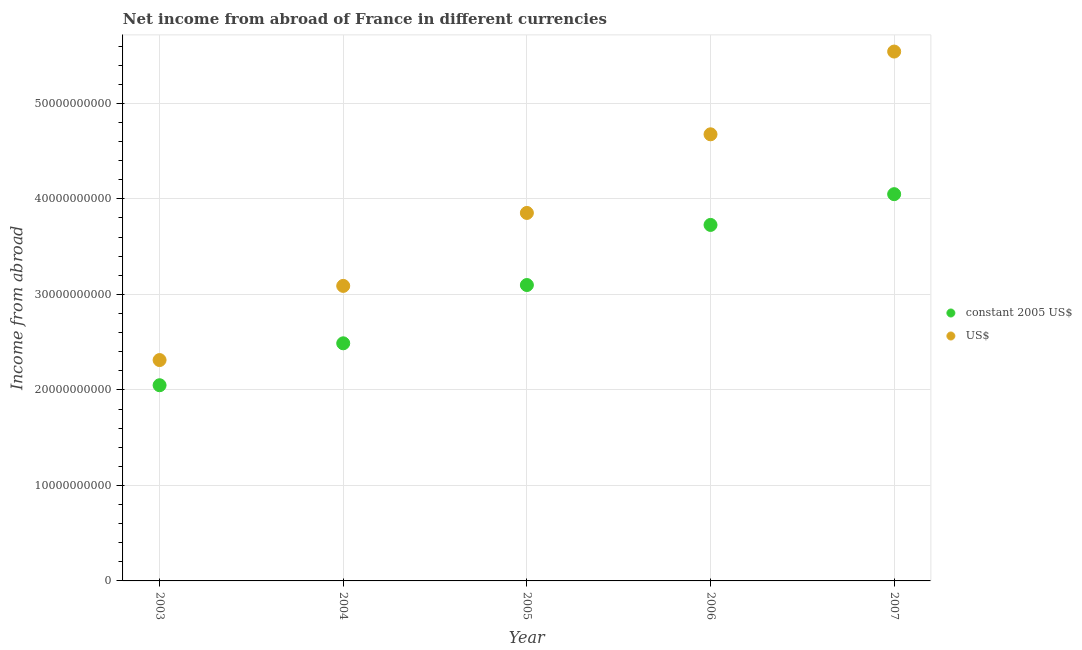Is the number of dotlines equal to the number of legend labels?
Provide a succinct answer. Yes. What is the income from abroad in us$ in 2007?
Provide a short and direct response. 5.54e+1. Across all years, what is the maximum income from abroad in us$?
Provide a succinct answer. 5.54e+1. Across all years, what is the minimum income from abroad in constant 2005 us$?
Make the answer very short. 2.05e+1. In which year was the income from abroad in us$ minimum?
Offer a terse response. 2003. What is the total income from abroad in us$ in the graph?
Your answer should be compact. 1.95e+11. What is the difference between the income from abroad in us$ in 2005 and that in 2006?
Your answer should be compact. -8.23e+09. What is the difference between the income from abroad in constant 2005 us$ in 2006 and the income from abroad in us$ in 2005?
Keep it short and to the point. -1.25e+09. What is the average income from abroad in constant 2005 us$ per year?
Offer a terse response. 3.08e+1. In the year 2006, what is the difference between the income from abroad in us$ and income from abroad in constant 2005 us$?
Your answer should be compact. 9.49e+09. What is the ratio of the income from abroad in constant 2005 us$ in 2003 to that in 2005?
Keep it short and to the point. 0.66. Is the income from abroad in constant 2005 us$ in 2003 less than that in 2007?
Your response must be concise. Yes. Is the difference between the income from abroad in us$ in 2004 and 2006 greater than the difference between the income from abroad in constant 2005 us$ in 2004 and 2006?
Your answer should be compact. No. What is the difference between the highest and the second highest income from abroad in constant 2005 us$?
Ensure brevity in your answer.  3.22e+09. What is the difference between the highest and the lowest income from abroad in constant 2005 us$?
Give a very brief answer. 2.00e+1. Does the income from abroad in us$ monotonically increase over the years?
Offer a very short reply. Yes. How many years are there in the graph?
Offer a terse response. 5. What is the difference between two consecutive major ticks on the Y-axis?
Give a very brief answer. 1.00e+1. Are the values on the major ticks of Y-axis written in scientific E-notation?
Provide a succinct answer. No. Does the graph contain any zero values?
Your response must be concise. No. How many legend labels are there?
Your answer should be compact. 2. How are the legend labels stacked?
Make the answer very short. Vertical. What is the title of the graph?
Make the answer very short. Net income from abroad of France in different currencies. Does "Young" appear as one of the legend labels in the graph?
Make the answer very short. No. What is the label or title of the Y-axis?
Your answer should be compact. Income from abroad. What is the Income from abroad of constant 2005 US$ in 2003?
Your response must be concise. 2.05e+1. What is the Income from abroad in US$ in 2003?
Give a very brief answer. 2.31e+1. What is the Income from abroad in constant 2005 US$ in 2004?
Your response must be concise. 2.49e+1. What is the Income from abroad of US$ in 2004?
Your answer should be compact. 3.09e+1. What is the Income from abroad of constant 2005 US$ in 2005?
Your answer should be very brief. 3.10e+1. What is the Income from abroad of US$ in 2005?
Ensure brevity in your answer.  3.85e+1. What is the Income from abroad in constant 2005 US$ in 2006?
Make the answer very short. 3.73e+1. What is the Income from abroad of US$ in 2006?
Make the answer very short. 4.68e+1. What is the Income from abroad of constant 2005 US$ in 2007?
Your answer should be compact. 4.05e+1. What is the Income from abroad of US$ in 2007?
Your answer should be compact. 5.54e+1. Across all years, what is the maximum Income from abroad of constant 2005 US$?
Provide a short and direct response. 4.05e+1. Across all years, what is the maximum Income from abroad in US$?
Your response must be concise. 5.54e+1. Across all years, what is the minimum Income from abroad of constant 2005 US$?
Offer a terse response. 2.05e+1. Across all years, what is the minimum Income from abroad of US$?
Your answer should be very brief. 2.31e+1. What is the total Income from abroad in constant 2005 US$ in the graph?
Offer a very short reply. 1.54e+11. What is the total Income from abroad in US$ in the graph?
Give a very brief answer. 1.95e+11. What is the difference between the Income from abroad of constant 2005 US$ in 2003 and that in 2004?
Offer a very short reply. -4.39e+09. What is the difference between the Income from abroad in US$ in 2003 and that in 2004?
Give a very brief answer. -7.76e+09. What is the difference between the Income from abroad in constant 2005 US$ in 2003 and that in 2005?
Make the answer very short. -1.05e+1. What is the difference between the Income from abroad in US$ in 2003 and that in 2005?
Your response must be concise. -1.54e+1. What is the difference between the Income from abroad in constant 2005 US$ in 2003 and that in 2006?
Provide a short and direct response. -1.68e+1. What is the difference between the Income from abroad in US$ in 2003 and that in 2006?
Ensure brevity in your answer.  -2.36e+1. What is the difference between the Income from abroad of constant 2005 US$ in 2003 and that in 2007?
Offer a very short reply. -2.00e+1. What is the difference between the Income from abroad of US$ in 2003 and that in 2007?
Offer a terse response. -3.23e+1. What is the difference between the Income from abroad of constant 2005 US$ in 2004 and that in 2005?
Make the answer very short. -6.10e+09. What is the difference between the Income from abroad of US$ in 2004 and that in 2005?
Your response must be concise. -7.64e+09. What is the difference between the Income from abroad in constant 2005 US$ in 2004 and that in 2006?
Offer a very short reply. -1.24e+1. What is the difference between the Income from abroad of US$ in 2004 and that in 2006?
Make the answer very short. -1.59e+1. What is the difference between the Income from abroad of constant 2005 US$ in 2004 and that in 2007?
Make the answer very short. -1.56e+1. What is the difference between the Income from abroad of US$ in 2004 and that in 2007?
Your response must be concise. -2.45e+1. What is the difference between the Income from abroad in constant 2005 US$ in 2005 and that in 2006?
Offer a very short reply. -6.29e+09. What is the difference between the Income from abroad of US$ in 2005 and that in 2006?
Give a very brief answer. -8.23e+09. What is the difference between the Income from abroad in constant 2005 US$ in 2005 and that in 2007?
Your answer should be compact. -9.51e+09. What is the difference between the Income from abroad of US$ in 2005 and that in 2007?
Offer a very short reply. -1.69e+1. What is the difference between the Income from abroad of constant 2005 US$ in 2006 and that in 2007?
Offer a very short reply. -3.22e+09. What is the difference between the Income from abroad in US$ in 2006 and that in 2007?
Provide a short and direct response. -8.66e+09. What is the difference between the Income from abroad of constant 2005 US$ in 2003 and the Income from abroad of US$ in 2004?
Make the answer very short. -1.04e+1. What is the difference between the Income from abroad of constant 2005 US$ in 2003 and the Income from abroad of US$ in 2005?
Provide a succinct answer. -1.80e+1. What is the difference between the Income from abroad in constant 2005 US$ in 2003 and the Income from abroad in US$ in 2006?
Give a very brief answer. -2.63e+1. What is the difference between the Income from abroad in constant 2005 US$ in 2003 and the Income from abroad in US$ in 2007?
Ensure brevity in your answer.  -3.49e+1. What is the difference between the Income from abroad in constant 2005 US$ in 2004 and the Income from abroad in US$ in 2005?
Provide a succinct answer. -1.36e+1. What is the difference between the Income from abroad of constant 2005 US$ in 2004 and the Income from abroad of US$ in 2006?
Your response must be concise. -2.19e+1. What is the difference between the Income from abroad of constant 2005 US$ in 2004 and the Income from abroad of US$ in 2007?
Your response must be concise. -3.05e+1. What is the difference between the Income from abroad in constant 2005 US$ in 2005 and the Income from abroad in US$ in 2006?
Your response must be concise. -1.58e+1. What is the difference between the Income from abroad of constant 2005 US$ in 2005 and the Income from abroad of US$ in 2007?
Give a very brief answer. -2.44e+1. What is the difference between the Income from abroad in constant 2005 US$ in 2006 and the Income from abroad in US$ in 2007?
Make the answer very short. -1.82e+1. What is the average Income from abroad of constant 2005 US$ per year?
Offer a very short reply. 3.08e+1. What is the average Income from abroad in US$ per year?
Give a very brief answer. 3.89e+1. In the year 2003, what is the difference between the Income from abroad of constant 2005 US$ and Income from abroad of US$?
Your answer should be compact. -2.64e+09. In the year 2004, what is the difference between the Income from abroad of constant 2005 US$ and Income from abroad of US$?
Provide a short and direct response. -6.01e+09. In the year 2005, what is the difference between the Income from abroad in constant 2005 US$ and Income from abroad in US$?
Give a very brief answer. -7.55e+09. In the year 2006, what is the difference between the Income from abroad in constant 2005 US$ and Income from abroad in US$?
Your answer should be compact. -9.49e+09. In the year 2007, what is the difference between the Income from abroad of constant 2005 US$ and Income from abroad of US$?
Give a very brief answer. -1.49e+1. What is the ratio of the Income from abroad of constant 2005 US$ in 2003 to that in 2004?
Ensure brevity in your answer.  0.82. What is the ratio of the Income from abroad of US$ in 2003 to that in 2004?
Provide a short and direct response. 0.75. What is the ratio of the Income from abroad of constant 2005 US$ in 2003 to that in 2005?
Give a very brief answer. 0.66. What is the ratio of the Income from abroad in US$ in 2003 to that in 2005?
Keep it short and to the point. 0.6. What is the ratio of the Income from abroad of constant 2005 US$ in 2003 to that in 2006?
Your response must be concise. 0.55. What is the ratio of the Income from abroad in US$ in 2003 to that in 2006?
Your answer should be compact. 0.49. What is the ratio of the Income from abroad of constant 2005 US$ in 2003 to that in 2007?
Give a very brief answer. 0.51. What is the ratio of the Income from abroad of US$ in 2003 to that in 2007?
Make the answer very short. 0.42. What is the ratio of the Income from abroad in constant 2005 US$ in 2004 to that in 2005?
Your answer should be very brief. 0.8. What is the ratio of the Income from abroad of US$ in 2004 to that in 2005?
Provide a succinct answer. 0.8. What is the ratio of the Income from abroad in constant 2005 US$ in 2004 to that in 2006?
Ensure brevity in your answer.  0.67. What is the ratio of the Income from abroad in US$ in 2004 to that in 2006?
Offer a very short reply. 0.66. What is the ratio of the Income from abroad in constant 2005 US$ in 2004 to that in 2007?
Provide a short and direct response. 0.61. What is the ratio of the Income from abroad of US$ in 2004 to that in 2007?
Offer a terse response. 0.56. What is the ratio of the Income from abroad of constant 2005 US$ in 2005 to that in 2006?
Your answer should be compact. 0.83. What is the ratio of the Income from abroad of US$ in 2005 to that in 2006?
Ensure brevity in your answer.  0.82. What is the ratio of the Income from abroad in constant 2005 US$ in 2005 to that in 2007?
Your answer should be compact. 0.77. What is the ratio of the Income from abroad of US$ in 2005 to that in 2007?
Offer a terse response. 0.7. What is the ratio of the Income from abroad of constant 2005 US$ in 2006 to that in 2007?
Give a very brief answer. 0.92. What is the ratio of the Income from abroad in US$ in 2006 to that in 2007?
Offer a terse response. 0.84. What is the difference between the highest and the second highest Income from abroad in constant 2005 US$?
Your answer should be compact. 3.22e+09. What is the difference between the highest and the second highest Income from abroad in US$?
Your answer should be very brief. 8.66e+09. What is the difference between the highest and the lowest Income from abroad of constant 2005 US$?
Keep it short and to the point. 2.00e+1. What is the difference between the highest and the lowest Income from abroad in US$?
Keep it short and to the point. 3.23e+1. 